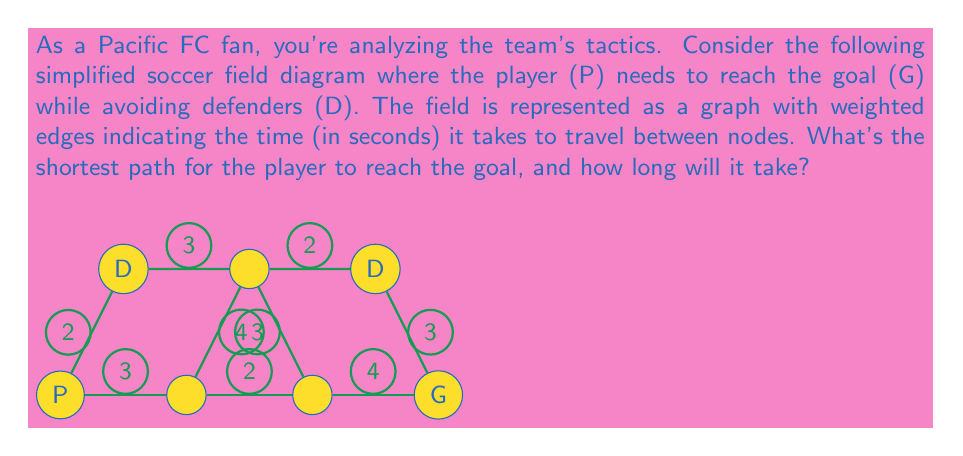Solve this math problem. To solve this problem, we'll use Dijkstra's algorithm to find the shortest path from P to G. Let's follow these steps:

1) Initialize:
   - Distance to P (start) = 0
   - Distance to all other nodes = $\infty$
   - Set of unvisited nodes = {P, B, C, E, F, G, G}

2) From P:
   - Update: d(B) = 3, d(E) = 2
   - Choose E (shortest distance)

3) From E:
   - Update: d(F) = 2 + 3 = 5
   - Choose B (next shortest distance)

4) From B:
   - Update: d(C) = 3 + 2 = 5, d(F) = min(5, 3 + 4) = 5
   - Choose C (next shortest distance)

5) From C:
   - Update: d(D) = 5 + 4 = 9, d(F) = min(5, 5 + 3) = 5
   - Choose F (next shortest distance)

6) From F:
   - Update: d(G) = 5 + 2 = 7
   - Choose G (next shortest distance)

7) From G:
   - Update: d(D) = min(9, 7 + 3) = 7
   - Choose D (goal reached)

The shortest path is P -> E -> F -> G -> D, with a total time of 7 seconds.
Answer: P -> E -> F -> G -> D, 7 seconds 